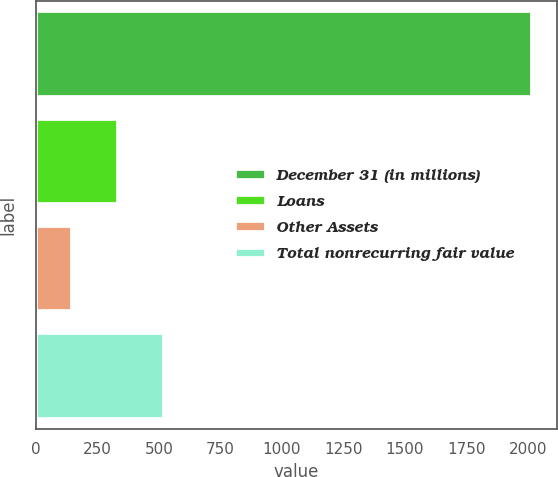Convert chart. <chart><loc_0><loc_0><loc_500><loc_500><bar_chart><fcel>December 31 (in millions)<fcel>Loans<fcel>Other Assets<fcel>Total nonrecurring fair value<nl><fcel>2017<fcel>334.9<fcel>148<fcel>521.8<nl></chart> 